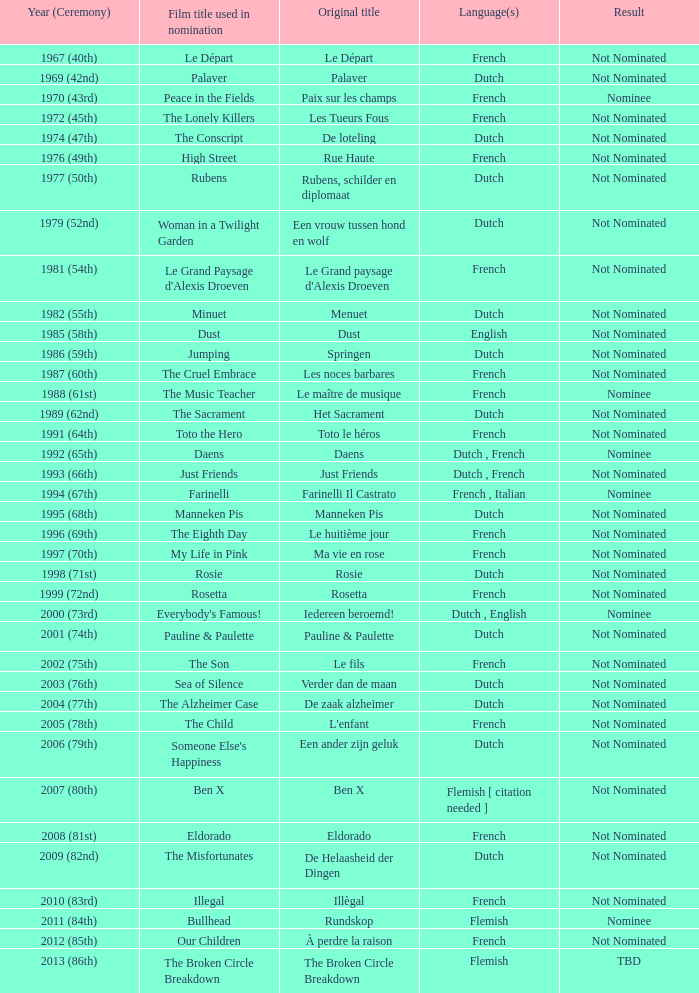In the dutch language nominations, what was the title given to the movie "rosie"? Rosie. 